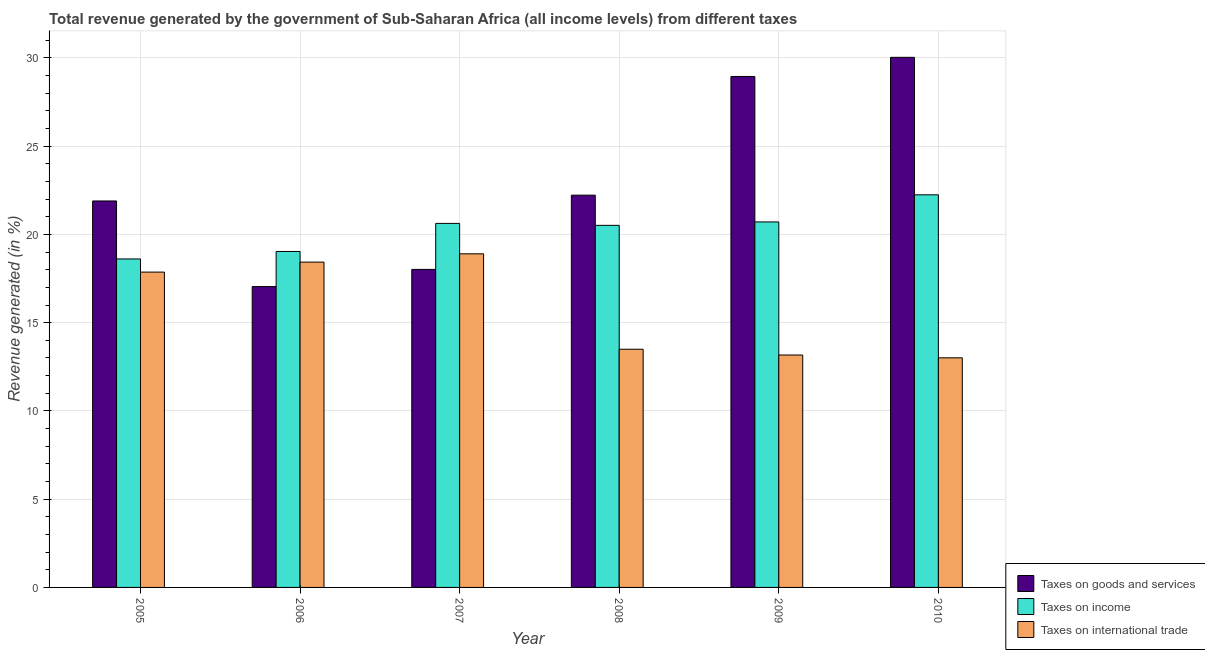How many different coloured bars are there?
Offer a very short reply. 3. Are the number of bars per tick equal to the number of legend labels?
Offer a very short reply. Yes. Are the number of bars on each tick of the X-axis equal?
Your answer should be compact. Yes. How many bars are there on the 5th tick from the right?
Offer a terse response. 3. In how many cases, is the number of bars for a given year not equal to the number of legend labels?
Your answer should be very brief. 0. What is the percentage of revenue generated by taxes on goods and services in 2008?
Ensure brevity in your answer.  22.23. Across all years, what is the maximum percentage of revenue generated by taxes on income?
Provide a succinct answer. 22.25. Across all years, what is the minimum percentage of revenue generated by taxes on goods and services?
Provide a short and direct response. 17.05. In which year was the percentage of revenue generated by taxes on income minimum?
Offer a very short reply. 2005. What is the total percentage of revenue generated by taxes on income in the graph?
Give a very brief answer. 121.75. What is the difference between the percentage of revenue generated by tax on international trade in 2007 and that in 2010?
Provide a succinct answer. 5.89. What is the difference between the percentage of revenue generated by taxes on income in 2006 and the percentage of revenue generated by taxes on goods and services in 2008?
Offer a very short reply. -1.48. What is the average percentage of revenue generated by taxes on goods and services per year?
Ensure brevity in your answer.  23.03. In the year 2008, what is the difference between the percentage of revenue generated by taxes on income and percentage of revenue generated by taxes on goods and services?
Make the answer very short. 0. In how many years, is the percentage of revenue generated by taxes on income greater than 12 %?
Provide a short and direct response. 6. What is the ratio of the percentage of revenue generated by taxes on goods and services in 2006 to that in 2010?
Provide a short and direct response. 0.57. Is the percentage of revenue generated by tax on international trade in 2006 less than that in 2010?
Ensure brevity in your answer.  No. What is the difference between the highest and the second highest percentage of revenue generated by taxes on goods and services?
Your answer should be very brief. 1.09. What is the difference between the highest and the lowest percentage of revenue generated by taxes on goods and services?
Your answer should be compact. 12.99. Is the sum of the percentage of revenue generated by taxes on goods and services in 2006 and 2009 greater than the maximum percentage of revenue generated by tax on international trade across all years?
Keep it short and to the point. Yes. What does the 1st bar from the left in 2008 represents?
Your answer should be very brief. Taxes on goods and services. What does the 3rd bar from the right in 2006 represents?
Ensure brevity in your answer.  Taxes on goods and services. How many years are there in the graph?
Ensure brevity in your answer.  6. What is the difference between two consecutive major ticks on the Y-axis?
Ensure brevity in your answer.  5. Does the graph contain any zero values?
Your answer should be very brief. No. Where does the legend appear in the graph?
Your response must be concise. Bottom right. How are the legend labels stacked?
Your answer should be very brief. Vertical. What is the title of the graph?
Your response must be concise. Total revenue generated by the government of Sub-Saharan Africa (all income levels) from different taxes. Does "Capital account" appear as one of the legend labels in the graph?
Ensure brevity in your answer.  No. What is the label or title of the X-axis?
Your answer should be compact. Year. What is the label or title of the Y-axis?
Ensure brevity in your answer.  Revenue generated (in %). What is the Revenue generated (in %) of Taxes on goods and services in 2005?
Your answer should be very brief. 21.9. What is the Revenue generated (in %) of Taxes on income in 2005?
Make the answer very short. 18.61. What is the Revenue generated (in %) in Taxes on international trade in 2005?
Keep it short and to the point. 17.87. What is the Revenue generated (in %) in Taxes on goods and services in 2006?
Your answer should be very brief. 17.05. What is the Revenue generated (in %) in Taxes on income in 2006?
Keep it short and to the point. 19.04. What is the Revenue generated (in %) of Taxes on international trade in 2006?
Your response must be concise. 18.43. What is the Revenue generated (in %) in Taxes on goods and services in 2007?
Keep it short and to the point. 18.02. What is the Revenue generated (in %) in Taxes on income in 2007?
Your answer should be very brief. 20.63. What is the Revenue generated (in %) of Taxes on international trade in 2007?
Give a very brief answer. 18.9. What is the Revenue generated (in %) of Taxes on goods and services in 2008?
Make the answer very short. 22.23. What is the Revenue generated (in %) of Taxes on income in 2008?
Offer a very short reply. 20.52. What is the Revenue generated (in %) in Taxes on international trade in 2008?
Provide a succinct answer. 13.5. What is the Revenue generated (in %) in Taxes on goods and services in 2009?
Provide a short and direct response. 28.95. What is the Revenue generated (in %) in Taxes on income in 2009?
Keep it short and to the point. 20.71. What is the Revenue generated (in %) in Taxes on international trade in 2009?
Provide a short and direct response. 13.17. What is the Revenue generated (in %) in Taxes on goods and services in 2010?
Your answer should be compact. 30.04. What is the Revenue generated (in %) of Taxes on income in 2010?
Make the answer very short. 22.25. What is the Revenue generated (in %) in Taxes on international trade in 2010?
Keep it short and to the point. 13.01. Across all years, what is the maximum Revenue generated (in %) in Taxes on goods and services?
Make the answer very short. 30.04. Across all years, what is the maximum Revenue generated (in %) in Taxes on income?
Make the answer very short. 22.25. Across all years, what is the maximum Revenue generated (in %) of Taxes on international trade?
Offer a terse response. 18.9. Across all years, what is the minimum Revenue generated (in %) in Taxes on goods and services?
Keep it short and to the point. 17.05. Across all years, what is the minimum Revenue generated (in %) in Taxes on income?
Ensure brevity in your answer.  18.61. Across all years, what is the minimum Revenue generated (in %) of Taxes on international trade?
Keep it short and to the point. 13.01. What is the total Revenue generated (in %) of Taxes on goods and services in the graph?
Keep it short and to the point. 138.18. What is the total Revenue generated (in %) in Taxes on income in the graph?
Offer a very short reply. 121.75. What is the total Revenue generated (in %) of Taxes on international trade in the graph?
Offer a terse response. 94.88. What is the difference between the Revenue generated (in %) in Taxes on goods and services in 2005 and that in 2006?
Keep it short and to the point. 4.85. What is the difference between the Revenue generated (in %) of Taxes on income in 2005 and that in 2006?
Give a very brief answer. -0.42. What is the difference between the Revenue generated (in %) of Taxes on international trade in 2005 and that in 2006?
Your answer should be compact. -0.57. What is the difference between the Revenue generated (in %) of Taxes on goods and services in 2005 and that in 2007?
Ensure brevity in your answer.  3.88. What is the difference between the Revenue generated (in %) in Taxes on income in 2005 and that in 2007?
Keep it short and to the point. -2.01. What is the difference between the Revenue generated (in %) of Taxes on international trade in 2005 and that in 2007?
Provide a short and direct response. -1.04. What is the difference between the Revenue generated (in %) in Taxes on goods and services in 2005 and that in 2008?
Ensure brevity in your answer.  -0.33. What is the difference between the Revenue generated (in %) of Taxes on income in 2005 and that in 2008?
Provide a succinct answer. -1.9. What is the difference between the Revenue generated (in %) in Taxes on international trade in 2005 and that in 2008?
Offer a very short reply. 4.37. What is the difference between the Revenue generated (in %) of Taxes on goods and services in 2005 and that in 2009?
Give a very brief answer. -7.05. What is the difference between the Revenue generated (in %) in Taxes on income in 2005 and that in 2009?
Your answer should be very brief. -2.1. What is the difference between the Revenue generated (in %) in Taxes on international trade in 2005 and that in 2009?
Provide a succinct answer. 4.7. What is the difference between the Revenue generated (in %) of Taxes on goods and services in 2005 and that in 2010?
Provide a short and direct response. -8.14. What is the difference between the Revenue generated (in %) of Taxes on income in 2005 and that in 2010?
Offer a very short reply. -3.63. What is the difference between the Revenue generated (in %) in Taxes on international trade in 2005 and that in 2010?
Offer a terse response. 4.86. What is the difference between the Revenue generated (in %) of Taxes on goods and services in 2006 and that in 2007?
Your response must be concise. -0.97. What is the difference between the Revenue generated (in %) in Taxes on income in 2006 and that in 2007?
Offer a very short reply. -1.59. What is the difference between the Revenue generated (in %) of Taxes on international trade in 2006 and that in 2007?
Your answer should be compact. -0.47. What is the difference between the Revenue generated (in %) of Taxes on goods and services in 2006 and that in 2008?
Offer a terse response. -5.18. What is the difference between the Revenue generated (in %) of Taxes on income in 2006 and that in 2008?
Ensure brevity in your answer.  -1.48. What is the difference between the Revenue generated (in %) of Taxes on international trade in 2006 and that in 2008?
Offer a terse response. 4.94. What is the difference between the Revenue generated (in %) of Taxes on goods and services in 2006 and that in 2009?
Your answer should be compact. -11.9. What is the difference between the Revenue generated (in %) in Taxes on income in 2006 and that in 2009?
Offer a terse response. -1.67. What is the difference between the Revenue generated (in %) of Taxes on international trade in 2006 and that in 2009?
Give a very brief answer. 5.26. What is the difference between the Revenue generated (in %) in Taxes on goods and services in 2006 and that in 2010?
Your answer should be compact. -12.99. What is the difference between the Revenue generated (in %) of Taxes on income in 2006 and that in 2010?
Provide a short and direct response. -3.21. What is the difference between the Revenue generated (in %) of Taxes on international trade in 2006 and that in 2010?
Keep it short and to the point. 5.42. What is the difference between the Revenue generated (in %) of Taxes on goods and services in 2007 and that in 2008?
Ensure brevity in your answer.  -4.21. What is the difference between the Revenue generated (in %) in Taxes on income in 2007 and that in 2008?
Offer a very short reply. 0.11. What is the difference between the Revenue generated (in %) in Taxes on international trade in 2007 and that in 2008?
Ensure brevity in your answer.  5.41. What is the difference between the Revenue generated (in %) of Taxes on goods and services in 2007 and that in 2009?
Your response must be concise. -10.93. What is the difference between the Revenue generated (in %) of Taxes on income in 2007 and that in 2009?
Give a very brief answer. -0.08. What is the difference between the Revenue generated (in %) in Taxes on international trade in 2007 and that in 2009?
Provide a succinct answer. 5.73. What is the difference between the Revenue generated (in %) of Taxes on goods and services in 2007 and that in 2010?
Ensure brevity in your answer.  -12.02. What is the difference between the Revenue generated (in %) in Taxes on income in 2007 and that in 2010?
Your response must be concise. -1.62. What is the difference between the Revenue generated (in %) of Taxes on international trade in 2007 and that in 2010?
Your answer should be very brief. 5.89. What is the difference between the Revenue generated (in %) in Taxes on goods and services in 2008 and that in 2009?
Your answer should be very brief. -6.72. What is the difference between the Revenue generated (in %) of Taxes on income in 2008 and that in 2009?
Offer a very short reply. -0.19. What is the difference between the Revenue generated (in %) of Taxes on international trade in 2008 and that in 2009?
Make the answer very short. 0.33. What is the difference between the Revenue generated (in %) of Taxes on goods and services in 2008 and that in 2010?
Ensure brevity in your answer.  -7.81. What is the difference between the Revenue generated (in %) of Taxes on income in 2008 and that in 2010?
Your response must be concise. -1.73. What is the difference between the Revenue generated (in %) of Taxes on international trade in 2008 and that in 2010?
Your response must be concise. 0.49. What is the difference between the Revenue generated (in %) in Taxes on goods and services in 2009 and that in 2010?
Give a very brief answer. -1.09. What is the difference between the Revenue generated (in %) in Taxes on income in 2009 and that in 2010?
Offer a terse response. -1.54. What is the difference between the Revenue generated (in %) in Taxes on international trade in 2009 and that in 2010?
Your response must be concise. 0.16. What is the difference between the Revenue generated (in %) of Taxes on goods and services in 2005 and the Revenue generated (in %) of Taxes on income in 2006?
Provide a short and direct response. 2.86. What is the difference between the Revenue generated (in %) of Taxes on goods and services in 2005 and the Revenue generated (in %) of Taxes on international trade in 2006?
Offer a very short reply. 3.47. What is the difference between the Revenue generated (in %) in Taxes on income in 2005 and the Revenue generated (in %) in Taxes on international trade in 2006?
Your answer should be very brief. 0.18. What is the difference between the Revenue generated (in %) in Taxes on goods and services in 2005 and the Revenue generated (in %) in Taxes on income in 2007?
Offer a terse response. 1.27. What is the difference between the Revenue generated (in %) of Taxes on goods and services in 2005 and the Revenue generated (in %) of Taxes on international trade in 2007?
Your response must be concise. 3. What is the difference between the Revenue generated (in %) in Taxes on income in 2005 and the Revenue generated (in %) in Taxes on international trade in 2007?
Provide a short and direct response. -0.29. What is the difference between the Revenue generated (in %) in Taxes on goods and services in 2005 and the Revenue generated (in %) in Taxes on income in 2008?
Provide a succinct answer. 1.38. What is the difference between the Revenue generated (in %) in Taxes on goods and services in 2005 and the Revenue generated (in %) in Taxes on international trade in 2008?
Make the answer very short. 8.4. What is the difference between the Revenue generated (in %) in Taxes on income in 2005 and the Revenue generated (in %) in Taxes on international trade in 2008?
Your answer should be very brief. 5.12. What is the difference between the Revenue generated (in %) in Taxes on goods and services in 2005 and the Revenue generated (in %) in Taxes on income in 2009?
Offer a terse response. 1.19. What is the difference between the Revenue generated (in %) in Taxes on goods and services in 2005 and the Revenue generated (in %) in Taxes on international trade in 2009?
Offer a terse response. 8.73. What is the difference between the Revenue generated (in %) of Taxes on income in 2005 and the Revenue generated (in %) of Taxes on international trade in 2009?
Your answer should be compact. 5.44. What is the difference between the Revenue generated (in %) in Taxes on goods and services in 2005 and the Revenue generated (in %) in Taxes on income in 2010?
Ensure brevity in your answer.  -0.35. What is the difference between the Revenue generated (in %) in Taxes on goods and services in 2005 and the Revenue generated (in %) in Taxes on international trade in 2010?
Offer a very short reply. 8.89. What is the difference between the Revenue generated (in %) of Taxes on income in 2005 and the Revenue generated (in %) of Taxes on international trade in 2010?
Your answer should be compact. 5.6. What is the difference between the Revenue generated (in %) in Taxes on goods and services in 2006 and the Revenue generated (in %) in Taxes on income in 2007?
Give a very brief answer. -3.58. What is the difference between the Revenue generated (in %) of Taxes on goods and services in 2006 and the Revenue generated (in %) of Taxes on international trade in 2007?
Ensure brevity in your answer.  -1.86. What is the difference between the Revenue generated (in %) of Taxes on income in 2006 and the Revenue generated (in %) of Taxes on international trade in 2007?
Provide a short and direct response. 0.13. What is the difference between the Revenue generated (in %) in Taxes on goods and services in 2006 and the Revenue generated (in %) in Taxes on income in 2008?
Give a very brief answer. -3.47. What is the difference between the Revenue generated (in %) of Taxes on goods and services in 2006 and the Revenue generated (in %) of Taxes on international trade in 2008?
Provide a succinct answer. 3.55. What is the difference between the Revenue generated (in %) in Taxes on income in 2006 and the Revenue generated (in %) in Taxes on international trade in 2008?
Ensure brevity in your answer.  5.54. What is the difference between the Revenue generated (in %) of Taxes on goods and services in 2006 and the Revenue generated (in %) of Taxes on income in 2009?
Your response must be concise. -3.66. What is the difference between the Revenue generated (in %) of Taxes on goods and services in 2006 and the Revenue generated (in %) of Taxes on international trade in 2009?
Keep it short and to the point. 3.88. What is the difference between the Revenue generated (in %) in Taxes on income in 2006 and the Revenue generated (in %) in Taxes on international trade in 2009?
Offer a terse response. 5.87. What is the difference between the Revenue generated (in %) in Taxes on goods and services in 2006 and the Revenue generated (in %) in Taxes on income in 2010?
Ensure brevity in your answer.  -5.2. What is the difference between the Revenue generated (in %) in Taxes on goods and services in 2006 and the Revenue generated (in %) in Taxes on international trade in 2010?
Provide a short and direct response. 4.04. What is the difference between the Revenue generated (in %) of Taxes on income in 2006 and the Revenue generated (in %) of Taxes on international trade in 2010?
Ensure brevity in your answer.  6.03. What is the difference between the Revenue generated (in %) in Taxes on goods and services in 2007 and the Revenue generated (in %) in Taxes on income in 2008?
Your answer should be very brief. -2.5. What is the difference between the Revenue generated (in %) of Taxes on goods and services in 2007 and the Revenue generated (in %) of Taxes on international trade in 2008?
Provide a succinct answer. 4.52. What is the difference between the Revenue generated (in %) in Taxes on income in 2007 and the Revenue generated (in %) in Taxes on international trade in 2008?
Your answer should be compact. 7.13. What is the difference between the Revenue generated (in %) of Taxes on goods and services in 2007 and the Revenue generated (in %) of Taxes on income in 2009?
Make the answer very short. -2.69. What is the difference between the Revenue generated (in %) of Taxes on goods and services in 2007 and the Revenue generated (in %) of Taxes on international trade in 2009?
Offer a terse response. 4.85. What is the difference between the Revenue generated (in %) of Taxes on income in 2007 and the Revenue generated (in %) of Taxes on international trade in 2009?
Provide a short and direct response. 7.46. What is the difference between the Revenue generated (in %) of Taxes on goods and services in 2007 and the Revenue generated (in %) of Taxes on income in 2010?
Offer a very short reply. -4.23. What is the difference between the Revenue generated (in %) in Taxes on goods and services in 2007 and the Revenue generated (in %) in Taxes on international trade in 2010?
Offer a terse response. 5.01. What is the difference between the Revenue generated (in %) of Taxes on income in 2007 and the Revenue generated (in %) of Taxes on international trade in 2010?
Your answer should be very brief. 7.62. What is the difference between the Revenue generated (in %) in Taxes on goods and services in 2008 and the Revenue generated (in %) in Taxes on income in 2009?
Offer a very short reply. 1.52. What is the difference between the Revenue generated (in %) in Taxes on goods and services in 2008 and the Revenue generated (in %) in Taxes on international trade in 2009?
Your answer should be compact. 9.06. What is the difference between the Revenue generated (in %) of Taxes on income in 2008 and the Revenue generated (in %) of Taxes on international trade in 2009?
Make the answer very short. 7.35. What is the difference between the Revenue generated (in %) in Taxes on goods and services in 2008 and the Revenue generated (in %) in Taxes on income in 2010?
Offer a very short reply. -0.02. What is the difference between the Revenue generated (in %) of Taxes on goods and services in 2008 and the Revenue generated (in %) of Taxes on international trade in 2010?
Your answer should be very brief. 9.22. What is the difference between the Revenue generated (in %) in Taxes on income in 2008 and the Revenue generated (in %) in Taxes on international trade in 2010?
Offer a very short reply. 7.51. What is the difference between the Revenue generated (in %) in Taxes on goods and services in 2009 and the Revenue generated (in %) in Taxes on income in 2010?
Provide a succinct answer. 6.71. What is the difference between the Revenue generated (in %) of Taxes on goods and services in 2009 and the Revenue generated (in %) of Taxes on international trade in 2010?
Offer a very short reply. 15.94. What is the difference between the Revenue generated (in %) of Taxes on income in 2009 and the Revenue generated (in %) of Taxes on international trade in 2010?
Your answer should be very brief. 7.7. What is the average Revenue generated (in %) in Taxes on goods and services per year?
Keep it short and to the point. 23.03. What is the average Revenue generated (in %) in Taxes on income per year?
Your answer should be compact. 20.29. What is the average Revenue generated (in %) of Taxes on international trade per year?
Your response must be concise. 15.81. In the year 2005, what is the difference between the Revenue generated (in %) of Taxes on goods and services and Revenue generated (in %) of Taxes on income?
Provide a short and direct response. 3.29. In the year 2005, what is the difference between the Revenue generated (in %) of Taxes on goods and services and Revenue generated (in %) of Taxes on international trade?
Give a very brief answer. 4.03. In the year 2005, what is the difference between the Revenue generated (in %) of Taxes on income and Revenue generated (in %) of Taxes on international trade?
Your response must be concise. 0.75. In the year 2006, what is the difference between the Revenue generated (in %) in Taxes on goods and services and Revenue generated (in %) in Taxes on income?
Your response must be concise. -1.99. In the year 2006, what is the difference between the Revenue generated (in %) in Taxes on goods and services and Revenue generated (in %) in Taxes on international trade?
Keep it short and to the point. -1.39. In the year 2006, what is the difference between the Revenue generated (in %) in Taxes on income and Revenue generated (in %) in Taxes on international trade?
Your response must be concise. 0.6. In the year 2007, what is the difference between the Revenue generated (in %) in Taxes on goods and services and Revenue generated (in %) in Taxes on income?
Give a very brief answer. -2.61. In the year 2007, what is the difference between the Revenue generated (in %) in Taxes on goods and services and Revenue generated (in %) in Taxes on international trade?
Your answer should be compact. -0.88. In the year 2007, what is the difference between the Revenue generated (in %) of Taxes on income and Revenue generated (in %) of Taxes on international trade?
Keep it short and to the point. 1.72. In the year 2008, what is the difference between the Revenue generated (in %) in Taxes on goods and services and Revenue generated (in %) in Taxes on income?
Offer a very short reply. 1.71. In the year 2008, what is the difference between the Revenue generated (in %) of Taxes on goods and services and Revenue generated (in %) of Taxes on international trade?
Your answer should be very brief. 8.73. In the year 2008, what is the difference between the Revenue generated (in %) of Taxes on income and Revenue generated (in %) of Taxes on international trade?
Provide a short and direct response. 7.02. In the year 2009, what is the difference between the Revenue generated (in %) of Taxes on goods and services and Revenue generated (in %) of Taxes on income?
Your response must be concise. 8.24. In the year 2009, what is the difference between the Revenue generated (in %) of Taxes on goods and services and Revenue generated (in %) of Taxes on international trade?
Offer a terse response. 15.78. In the year 2009, what is the difference between the Revenue generated (in %) of Taxes on income and Revenue generated (in %) of Taxes on international trade?
Give a very brief answer. 7.54. In the year 2010, what is the difference between the Revenue generated (in %) of Taxes on goods and services and Revenue generated (in %) of Taxes on income?
Your answer should be compact. 7.79. In the year 2010, what is the difference between the Revenue generated (in %) in Taxes on goods and services and Revenue generated (in %) in Taxes on international trade?
Offer a very short reply. 17.03. In the year 2010, what is the difference between the Revenue generated (in %) in Taxes on income and Revenue generated (in %) in Taxes on international trade?
Ensure brevity in your answer.  9.24. What is the ratio of the Revenue generated (in %) in Taxes on goods and services in 2005 to that in 2006?
Offer a very short reply. 1.28. What is the ratio of the Revenue generated (in %) in Taxes on income in 2005 to that in 2006?
Your response must be concise. 0.98. What is the ratio of the Revenue generated (in %) in Taxes on international trade in 2005 to that in 2006?
Your response must be concise. 0.97. What is the ratio of the Revenue generated (in %) in Taxes on goods and services in 2005 to that in 2007?
Offer a very short reply. 1.22. What is the ratio of the Revenue generated (in %) of Taxes on income in 2005 to that in 2007?
Provide a short and direct response. 0.9. What is the ratio of the Revenue generated (in %) of Taxes on international trade in 2005 to that in 2007?
Your response must be concise. 0.95. What is the ratio of the Revenue generated (in %) of Taxes on goods and services in 2005 to that in 2008?
Your answer should be very brief. 0.99. What is the ratio of the Revenue generated (in %) of Taxes on income in 2005 to that in 2008?
Give a very brief answer. 0.91. What is the ratio of the Revenue generated (in %) of Taxes on international trade in 2005 to that in 2008?
Provide a succinct answer. 1.32. What is the ratio of the Revenue generated (in %) in Taxes on goods and services in 2005 to that in 2009?
Offer a very short reply. 0.76. What is the ratio of the Revenue generated (in %) of Taxes on income in 2005 to that in 2009?
Your answer should be compact. 0.9. What is the ratio of the Revenue generated (in %) in Taxes on international trade in 2005 to that in 2009?
Your answer should be compact. 1.36. What is the ratio of the Revenue generated (in %) of Taxes on goods and services in 2005 to that in 2010?
Give a very brief answer. 0.73. What is the ratio of the Revenue generated (in %) of Taxes on income in 2005 to that in 2010?
Your answer should be compact. 0.84. What is the ratio of the Revenue generated (in %) of Taxes on international trade in 2005 to that in 2010?
Make the answer very short. 1.37. What is the ratio of the Revenue generated (in %) in Taxes on goods and services in 2006 to that in 2007?
Provide a short and direct response. 0.95. What is the ratio of the Revenue generated (in %) of Taxes on income in 2006 to that in 2007?
Offer a terse response. 0.92. What is the ratio of the Revenue generated (in %) of Taxes on international trade in 2006 to that in 2007?
Give a very brief answer. 0.98. What is the ratio of the Revenue generated (in %) in Taxes on goods and services in 2006 to that in 2008?
Offer a very short reply. 0.77. What is the ratio of the Revenue generated (in %) of Taxes on income in 2006 to that in 2008?
Your answer should be very brief. 0.93. What is the ratio of the Revenue generated (in %) in Taxes on international trade in 2006 to that in 2008?
Give a very brief answer. 1.37. What is the ratio of the Revenue generated (in %) of Taxes on goods and services in 2006 to that in 2009?
Offer a terse response. 0.59. What is the ratio of the Revenue generated (in %) in Taxes on income in 2006 to that in 2009?
Your response must be concise. 0.92. What is the ratio of the Revenue generated (in %) of Taxes on international trade in 2006 to that in 2009?
Your response must be concise. 1.4. What is the ratio of the Revenue generated (in %) of Taxes on goods and services in 2006 to that in 2010?
Make the answer very short. 0.57. What is the ratio of the Revenue generated (in %) of Taxes on income in 2006 to that in 2010?
Offer a very short reply. 0.86. What is the ratio of the Revenue generated (in %) of Taxes on international trade in 2006 to that in 2010?
Give a very brief answer. 1.42. What is the ratio of the Revenue generated (in %) in Taxes on goods and services in 2007 to that in 2008?
Your response must be concise. 0.81. What is the ratio of the Revenue generated (in %) in Taxes on income in 2007 to that in 2008?
Keep it short and to the point. 1.01. What is the ratio of the Revenue generated (in %) of Taxes on international trade in 2007 to that in 2008?
Your answer should be very brief. 1.4. What is the ratio of the Revenue generated (in %) of Taxes on goods and services in 2007 to that in 2009?
Keep it short and to the point. 0.62. What is the ratio of the Revenue generated (in %) in Taxes on income in 2007 to that in 2009?
Your answer should be compact. 1. What is the ratio of the Revenue generated (in %) of Taxes on international trade in 2007 to that in 2009?
Ensure brevity in your answer.  1.44. What is the ratio of the Revenue generated (in %) in Taxes on goods and services in 2007 to that in 2010?
Make the answer very short. 0.6. What is the ratio of the Revenue generated (in %) in Taxes on income in 2007 to that in 2010?
Provide a short and direct response. 0.93. What is the ratio of the Revenue generated (in %) of Taxes on international trade in 2007 to that in 2010?
Your answer should be very brief. 1.45. What is the ratio of the Revenue generated (in %) in Taxes on goods and services in 2008 to that in 2009?
Provide a short and direct response. 0.77. What is the ratio of the Revenue generated (in %) in Taxes on international trade in 2008 to that in 2009?
Offer a very short reply. 1.02. What is the ratio of the Revenue generated (in %) in Taxes on goods and services in 2008 to that in 2010?
Your answer should be very brief. 0.74. What is the ratio of the Revenue generated (in %) of Taxes on income in 2008 to that in 2010?
Give a very brief answer. 0.92. What is the ratio of the Revenue generated (in %) of Taxes on international trade in 2008 to that in 2010?
Offer a terse response. 1.04. What is the ratio of the Revenue generated (in %) in Taxes on goods and services in 2009 to that in 2010?
Provide a short and direct response. 0.96. What is the ratio of the Revenue generated (in %) of Taxes on income in 2009 to that in 2010?
Provide a short and direct response. 0.93. What is the ratio of the Revenue generated (in %) of Taxes on international trade in 2009 to that in 2010?
Your response must be concise. 1.01. What is the difference between the highest and the second highest Revenue generated (in %) in Taxes on goods and services?
Your answer should be compact. 1.09. What is the difference between the highest and the second highest Revenue generated (in %) of Taxes on income?
Provide a succinct answer. 1.54. What is the difference between the highest and the second highest Revenue generated (in %) of Taxes on international trade?
Your answer should be compact. 0.47. What is the difference between the highest and the lowest Revenue generated (in %) of Taxes on goods and services?
Your response must be concise. 12.99. What is the difference between the highest and the lowest Revenue generated (in %) of Taxes on income?
Make the answer very short. 3.63. What is the difference between the highest and the lowest Revenue generated (in %) of Taxes on international trade?
Your answer should be compact. 5.89. 